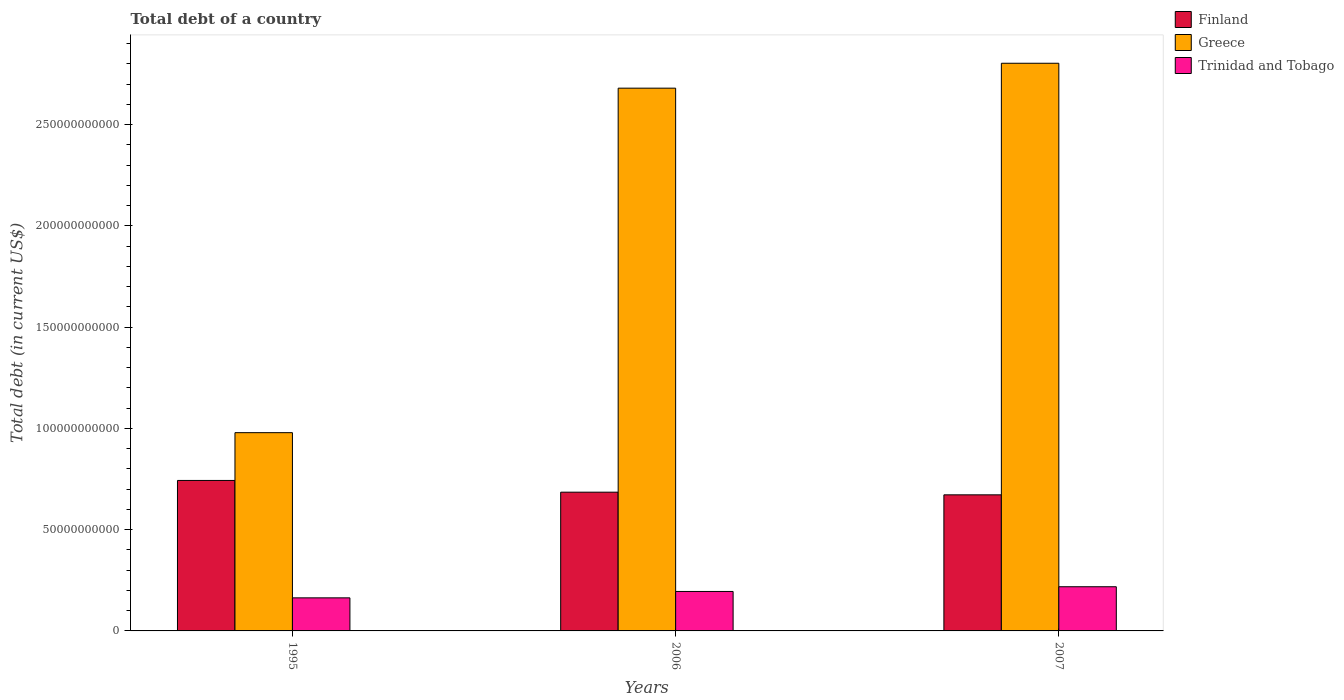How many groups of bars are there?
Make the answer very short. 3. Are the number of bars on each tick of the X-axis equal?
Your answer should be compact. Yes. What is the debt in Trinidad and Tobago in 2007?
Make the answer very short. 2.18e+1. Across all years, what is the maximum debt in Greece?
Keep it short and to the point. 2.80e+11. Across all years, what is the minimum debt in Finland?
Provide a short and direct response. 6.72e+1. In which year was the debt in Trinidad and Tobago maximum?
Provide a succinct answer. 2007. In which year was the debt in Greece minimum?
Your response must be concise. 1995. What is the total debt in Greece in the graph?
Keep it short and to the point. 6.46e+11. What is the difference between the debt in Trinidad and Tobago in 1995 and that in 2006?
Give a very brief answer. -3.16e+09. What is the difference between the debt in Trinidad and Tobago in 2006 and the debt in Greece in 1995?
Offer a terse response. -7.84e+1. What is the average debt in Trinidad and Tobago per year?
Provide a short and direct response. 1.92e+1. In the year 2006, what is the difference between the debt in Greece and debt in Finland?
Your answer should be very brief. 2.00e+11. In how many years, is the debt in Trinidad and Tobago greater than 240000000000 US$?
Provide a short and direct response. 0. What is the ratio of the debt in Finland in 1995 to that in 2007?
Your answer should be compact. 1.11. Is the debt in Greece in 1995 less than that in 2007?
Ensure brevity in your answer.  Yes. Is the difference between the debt in Greece in 1995 and 2007 greater than the difference between the debt in Finland in 1995 and 2007?
Offer a very short reply. No. What is the difference between the highest and the second highest debt in Greece?
Keep it short and to the point. 1.23e+1. What is the difference between the highest and the lowest debt in Finland?
Provide a short and direct response. 7.10e+09. Is the sum of the debt in Trinidad and Tobago in 2006 and 2007 greater than the maximum debt in Greece across all years?
Offer a terse response. No. What does the 1st bar from the left in 2006 represents?
Provide a short and direct response. Finland. How many years are there in the graph?
Your answer should be compact. 3. What is the difference between two consecutive major ticks on the Y-axis?
Provide a short and direct response. 5.00e+1. Does the graph contain any zero values?
Provide a short and direct response. No. Where does the legend appear in the graph?
Keep it short and to the point. Top right. What is the title of the graph?
Provide a succinct answer. Total debt of a country. Does "Congo (Republic)" appear as one of the legend labels in the graph?
Your answer should be compact. No. What is the label or title of the X-axis?
Your response must be concise. Years. What is the label or title of the Y-axis?
Your answer should be compact. Total debt (in current US$). What is the Total debt (in current US$) of Finland in 1995?
Offer a very short reply. 7.43e+1. What is the Total debt (in current US$) of Greece in 1995?
Offer a very short reply. 9.79e+1. What is the Total debt (in current US$) in Trinidad and Tobago in 1995?
Offer a terse response. 1.63e+1. What is the Total debt (in current US$) of Finland in 2006?
Keep it short and to the point. 6.85e+1. What is the Total debt (in current US$) in Greece in 2006?
Your response must be concise. 2.68e+11. What is the Total debt (in current US$) of Trinidad and Tobago in 2006?
Make the answer very short. 1.95e+1. What is the Total debt (in current US$) of Finland in 2007?
Keep it short and to the point. 6.72e+1. What is the Total debt (in current US$) in Greece in 2007?
Your answer should be compact. 2.80e+11. What is the Total debt (in current US$) of Trinidad and Tobago in 2007?
Make the answer very short. 2.18e+1. Across all years, what is the maximum Total debt (in current US$) of Finland?
Provide a short and direct response. 7.43e+1. Across all years, what is the maximum Total debt (in current US$) in Greece?
Your answer should be very brief. 2.80e+11. Across all years, what is the maximum Total debt (in current US$) in Trinidad and Tobago?
Your answer should be very brief. 2.18e+1. Across all years, what is the minimum Total debt (in current US$) of Finland?
Your answer should be compact. 6.72e+1. Across all years, what is the minimum Total debt (in current US$) in Greece?
Provide a short and direct response. 9.79e+1. Across all years, what is the minimum Total debt (in current US$) of Trinidad and Tobago?
Your answer should be compact. 1.63e+1. What is the total Total debt (in current US$) in Finland in the graph?
Your answer should be compact. 2.10e+11. What is the total Total debt (in current US$) in Greece in the graph?
Offer a very short reply. 6.46e+11. What is the total Total debt (in current US$) of Trinidad and Tobago in the graph?
Provide a succinct answer. 5.76e+1. What is the difference between the Total debt (in current US$) of Finland in 1995 and that in 2006?
Offer a very short reply. 5.79e+09. What is the difference between the Total debt (in current US$) in Greece in 1995 and that in 2006?
Offer a very short reply. -1.70e+11. What is the difference between the Total debt (in current US$) of Trinidad and Tobago in 1995 and that in 2006?
Make the answer very short. -3.16e+09. What is the difference between the Total debt (in current US$) of Finland in 1995 and that in 2007?
Give a very brief answer. 7.10e+09. What is the difference between the Total debt (in current US$) of Greece in 1995 and that in 2007?
Offer a terse response. -1.82e+11. What is the difference between the Total debt (in current US$) of Trinidad and Tobago in 1995 and that in 2007?
Offer a very short reply. -5.49e+09. What is the difference between the Total debt (in current US$) in Finland in 2006 and that in 2007?
Offer a very short reply. 1.32e+09. What is the difference between the Total debt (in current US$) of Greece in 2006 and that in 2007?
Offer a very short reply. -1.23e+1. What is the difference between the Total debt (in current US$) in Trinidad and Tobago in 2006 and that in 2007?
Provide a short and direct response. -2.33e+09. What is the difference between the Total debt (in current US$) in Finland in 1995 and the Total debt (in current US$) in Greece in 2006?
Offer a very short reply. -1.94e+11. What is the difference between the Total debt (in current US$) in Finland in 1995 and the Total debt (in current US$) in Trinidad and Tobago in 2006?
Ensure brevity in your answer.  5.48e+1. What is the difference between the Total debt (in current US$) in Greece in 1995 and the Total debt (in current US$) in Trinidad and Tobago in 2006?
Offer a very short reply. 7.84e+1. What is the difference between the Total debt (in current US$) of Finland in 1995 and the Total debt (in current US$) of Greece in 2007?
Offer a terse response. -2.06e+11. What is the difference between the Total debt (in current US$) in Finland in 1995 and the Total debt (in current US$) in Trinidad and Tobago in 2007?
Provide a succinct answer. 5.25e+1. What is the difference between the Total debt (in current US$) of Greece in 1995 and the Total debt (in current US$) of Trinidad and Tobago in 2007?
Your response must be concise. 7.61e+1. What is the difference between the Total debt (in current US$) of Finland in 2006 and the Total debt (in current US$) of Greece in 2007?
Make the answer very short. -2.12e+11. What is the difference between the Total debt (in current US$) of Finland in 2006 and the Total debt (in current US$) of Trinidad and Tobago in 2007?
Give a very brief answer. 4.67e+1. What is the difference between the Total debt (in current US$) of Greece in 2006 and the Total debt (in current US$) of Trinidad and Tobago in 2007?
Your response must be concise. 2.46e+11. What is the average Total debt (in current US$) in Finland per year?
Offer a terse response. 7.00e+1. What is the average Total debt (in current US$) in Greece per year?
Give a very brief answer. 2.15e+11. What is the average Total debt (in current US$) in Trinidad and Tobago per year?
Offer a terse response. 1.92e+1. In the year 1995, what is the difference between the Total debt (in current US$) of Finland and Total debt (in current US$) of Greece?
Make the answer very short. -2.36e+1. In the year 1995, what is the difference between the Total debt (in current US$) of Finland and Total debt (in current US$) of Trinidad and Tobago?
Give a very brief answer. 5.80e+1. In the year 1995, what is the difference between the Total debt (in current US$) in Greece and Total debt (in current US$) in Trinidad and Tobago?
Your answer should be very brief. 8.16e+1. In the year 2006, what is the difference between the Total debt (in current US$) in Finland and Total debt (in current US$) in Greece?
Ensure brevity in your answer.  -2.00e+11. In the year 2006, what is the difference between the Total debt (in current US$) of Finland and Total debt (in current US$) of Trinidad and Tobago?
Your answer should be compact. 4.90e+1. In the year 2006, what is the difference between the Total debt (in current US$) in Greece and Total debt (in current US$) in Trinidad and Tobago?
Make the answer very short. 2.49e+11. In the year 2007, what is the difference between the Total debt (in current US$) in Finland and Total debt (in current US$) in Greece?
Give a very brief answer. -2.13e+11. In the year 2007, what is the difference between the Total debt (in current US$) of Finland and Total debt (in current US$) of Trinidad and Tobago?
Give a very brief answer. 4.54e+1. In the year 2007, what is the difference between the Total debt (in current US$) in Greece and Total debt (in current US$) in Trinidad and Tobago?
Give a very brief answer. 2.58e+11. What is the ratio of the Total debt (in current US$) of Finland in 1995 to that in 2006?
Offer a terse response. 1.08. What is the ratio of the Total debt (in current US$) of Greece in 1995 to that in 2006?
Ensure brevity in your answer.  0.37. What is the ratio of the Total debt (in current US$) in Trinidad and Tobago in 1995 to that in 2006?
Your response must be concise. 0.84. What is the ratio of the Total debt (in current US$) in Finland in 1995 to that in 2007?
Keep it short and to the point. 1.11. What is the ratio of the Total debt (in current US$) of Greece in 1995 to that in 2007?
Provide a short and direct response. 0.35. What is the ratio of the Total debt (in current US$) in Trinidad and Tobago in 1995 to that in 2007?
Give a very brief answer. 0.75. What is the ratio of the Total debt (in current US$) in Finland in 2006 to that in 2007?
Your answer should be very brief. 1.02. What is the ratio of the Total debt (in current US$) in Greece in 2006 to that in 2007?
Ensure brevity in your answer.  0.96. What is the ratio of the Total debt (in current US$) of Trinidad and Tobago in 2006 to that in 2007?
Offer a terse response. 0.89. What is the difference between the highest and the second highest Total debt (in current US$) in Finland?
Offer a terse response. 5.79e+09. What is the difference between the highest and the second highest Total debt (in current US$) in Greece?
Make the answer very short. 1.23e+1. What is the difference between the highest and the second highest Total debt (in current US$) in Trinidad and Tobago?
Your answer should be compact. 2.33e+09. What is the difference between the highest and the lowest Total debt (in current US$) in Finland?
Offer a terse response. 7.10e+09. What is the difference between the highest and the lowest Total debt (in current US$) of Greece?
Your answer should be compact. 1.82e+11. What is the difference between the highest and the lowest Total debt (in current US$) in Trinidad and Tobago?
Give a very brief answer. 5.49e+09. 